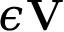Convert formula to latex. <formula><loc_0><loc_0><loc_500><loc_500>\epsilon { \mathbf V }</formula> 